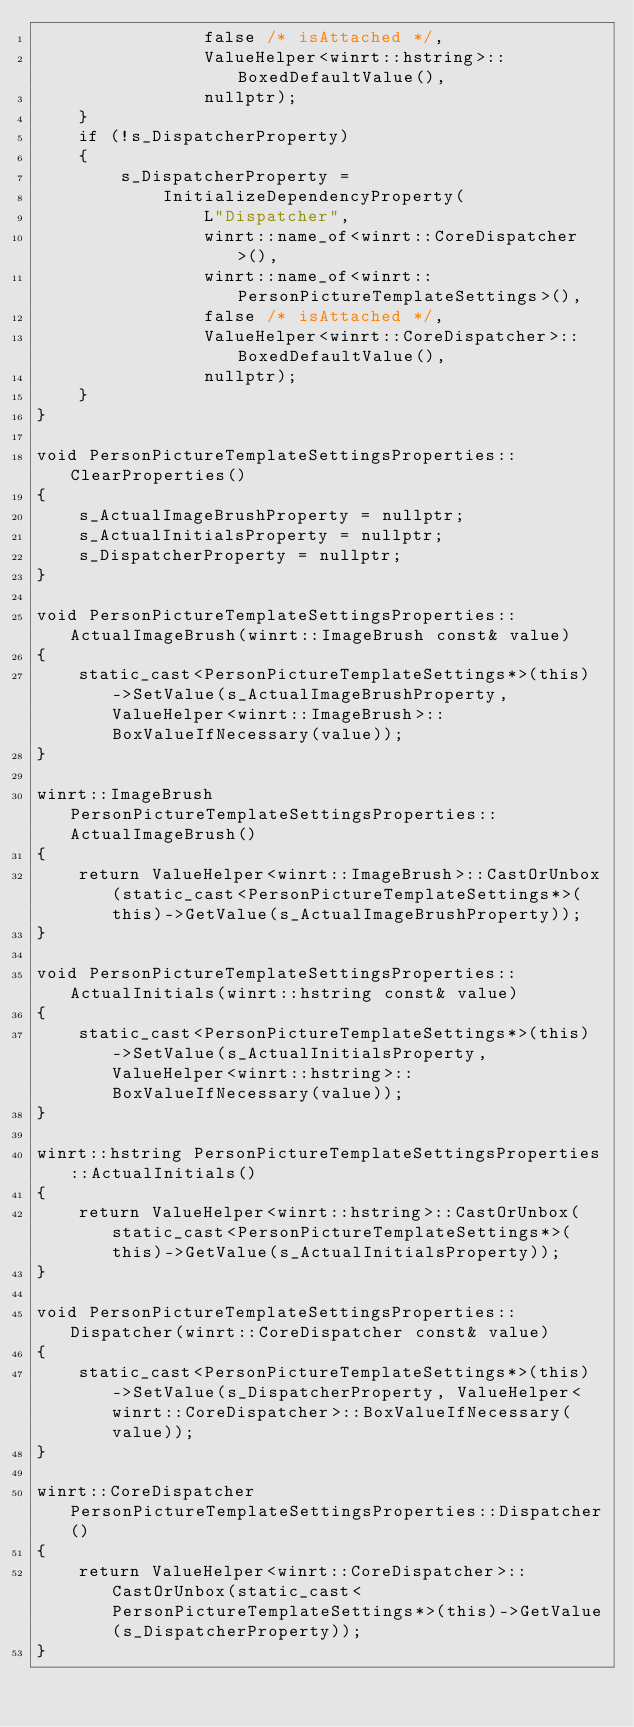<code> <loc_0><loc_0><loc_500><loc_500><_C++_>                false /* isAttached */,
                ValueHelper<winrt::hstring>::BoxedDefaultValue(),
                nullptr);
    }
    if (!s_DispatcherProperty)
    {
        s_DispatcherProperty =
            InitializeDependencyProperty(
                L"Dispatcher",
                winrt::name_of<winrt::CoreDispatcher>(),
                winrt::name_of<winrt::PersonPictureTemplateSettings>(),
                false /* isAttached */,
                ValueHelper<winrt::CoreDispatcher>::BoxedDefaultValue(),
                nullptr);
    }
}

void PersonPictureTemplateSettingsProperties::ClearProperties()
{
    s_ActualImageBrushProperty = nullptr;
    s_ActualInitialsProperty = nullptr;
    s_DispatcherProperty = nullptr;
}

void PersonPictureTemplateSettingsProperties::ActualImageBrush(winrt::ImageBrush const& value)
{
    static_cast<PersonPictureTemplateSettings*>(this)->SetValue(s_ActualImageBrushProperty, ValueHelper<winrt::ImageBrush>::BoxValueIfNecessary(value));
}

winrt::ImageBrush PersonPictureTemplateSettingsProperties::ActualImageBrush()
{
    return ValueHelper<winrt::ImageBrush>::CastOrUnbox(static_cast<PersonPictureTemplateSettings*>(this)->GetValue(s_ActualImageBrushProperty));
}

void PersonPictureTemplateSettingsProperties::ActualInitials(winrt::hstring const& value)
{
    static_cast<PersonPictureTemplateSettings*>(this)->SetValue(s_ActualInitialsProperty, ValueHelper<winrt::hstring>::BoxValueIfNecessary(value));
}

winrt::hstring PersonPictureTemplateSettingsProperties::ActualInitials()
{
    return ValueHelper<winrt::hstring>::CastOrUnbox(static_cast<PersonPictureTemplateSettings*>(this)->GetValue(s_ActualInitialsProperty));
}

void PersonPictureTemplateSettingsProperties::Dispatcher(winrt::CoreDispatcher const& value)
{
    static_cast<PersonPictureTemplateSettings*>(this)->SetValue(s_DispatcherProperty, ValueHelper<winrt::CoreDispatcher>::BoxValueIfNecessary(value));
}

winrt::CoreDispatcher PersonPictureTemplateSettingsProperties::Dispatcher()
{
    return ValueHelper<winrt::CoreDispatcher>::CastOrUnbox(static_cast<PersonPictureTemplateSettings*>(this)->GetValue(s_DispatcherProperty));
}
</code> 